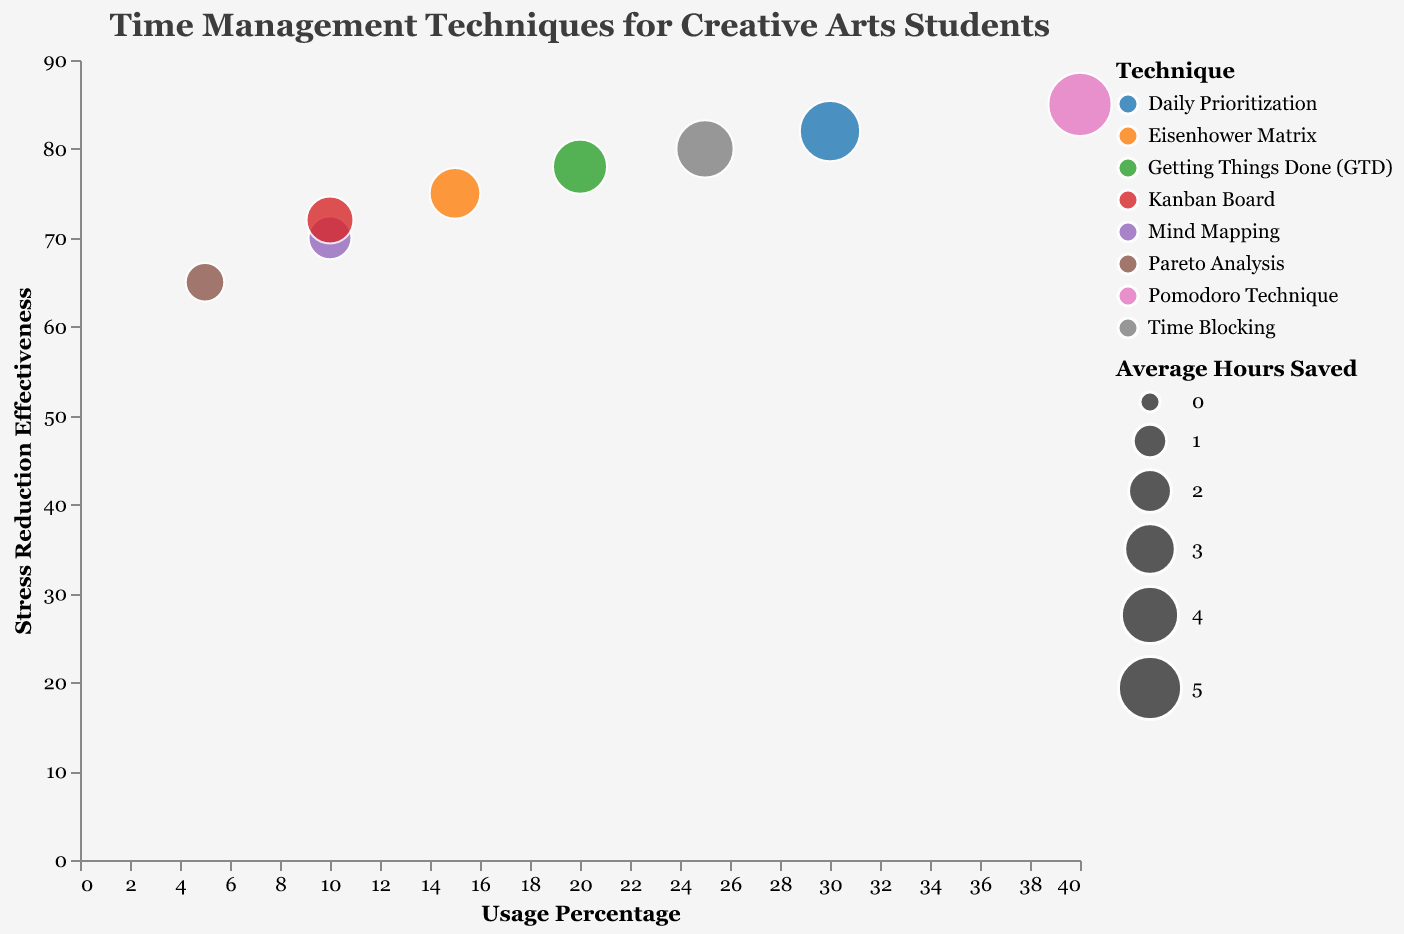How many time management techniques are displayed in the bubble chart? The data provides information about eight different time management techniques used by creative arts students. Each technique corresponds to one data point on the chart. Count the number of unique entries under the "Time Management Technique" category.
Answer: 8 Which time management technique has the highest stress reduction effectiveness? By checking the y-axis values corresponding to each technique, we find that the "Pomodoro Technique" has the highest stress reduction effectiveness at 85.
Answer: Pomodoro Technique What is the usage percentage of the time management technique with the lowest average hours saved? "Pareto Analysis" has the lowest average hours saved at 1.5. The usage percentage for “Pareto Analysis” is given as 5%.
Answer: 5% Which technique is used by the most students? The tooltip information or counting the bubbles shows the student count values. "Pomodoro Technique" is used by 30 students, the highest among all the techniques listed.
Answer: Pomodoro Technique Compare the stress reduction effectiveness between "Time Blocking" and "Kanban Board". Which is higher and by how much? The chart shows "Time Blocking" has a stress reduction effectiveness of 80 and "Kanban Board" has 72. Subtracting these values, 80 - 72 = 8, we find that "Time Blocking" is higher by 8 points.
Answer: "Time Blocking" is higher by 8 points What is the average usage percentage of the techniques that save 4 hours or more? Identify techniques with "Average Hours Saved" of 4 or more: "Pomodoro Technique" (40%), "Time Blocking" (25%), and "Daily Prioritization" (30%). Calculate the average: (40 + 25 + 30) / 3 = 95 / 3 ≈ 31.67.
Answer: 31.67 Which technique saves more average hours, "Getting Things Done (GTD)" or "Eisenhower Matrix"? From the data, "Getting Things Done (GTD)" saves an average of 3.5 hours, while "Eisenhower Matrix" saves 3 hours. Hence, "Getting Things Done (GTD)" saves more hours.
Answer: Getting Things Done (GTD) What is the relationship between usage percentage and stress reduction effectiveness for "Kanban Board"? Look at the position of "Kanban Board" on both the x-axis (Usage Percentage) and y-axis (Stress Reduction Effectiveness). It has a usage percentage of 10 and a stress reduction effectiveness of 72, suggesting a moderate but not very widely used technique.
Answer: 10% usage and 72 effectiveness What technique has the second highest average hours saved, and how effective is it in stress reduction? The second highest average hours saved is 4.5 by "Daily Prioritization", which has a stress reduction effectiveness of 82 as shown on the x and y axes.
Answer: Daily Prioritization, 82 